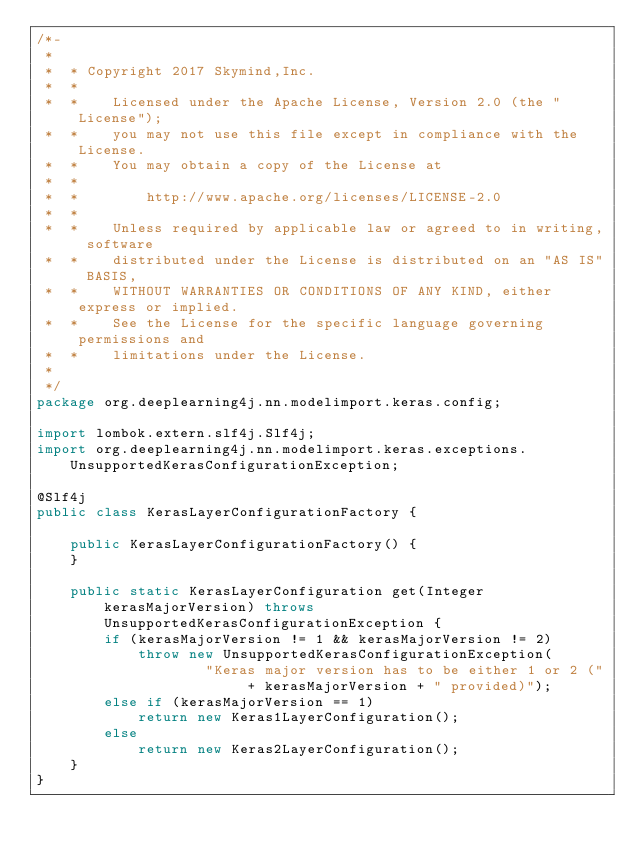<code> <loc_0><loc_0><loc_500><loc_500><_Java_>/*-
 *
 *  * Copyright 2017 Skymind,Inc.
 *  *
 *  *    Licensed under the Apache License, Version 2.0 (the "License");
 *  *    you may not use this file except in compliance with the License.
 *  *    You may obtain a copy of the License at
 *  *
 *  *        http://www.apache.org/licenses/LICENSE-2.0
 *  *
 *  *    Unless required by applicable law or agreed to in writing, software
 *  *    distributed under the License is distributed on an "AS IS" BASIS,
 *  *    WITHOUT WARRANTIES OR CONDITIONS OF ANY KIND, either express or implied.
 *  *    See the License for the specific language governing permissions and
 *  *    limitations under the License.
 *
 */
package org.deeplearning4j.nn.modelimport.keras.config;

import lombok.extern.slf4j.Slf4j;
import org.deeplearning4j.nn.modelimport.keras.exceptions.UnsupportedKerasConfigurationException;

@Slf4j
public class KerasLayerConfigurationFactory {

    public KerasLayerConfigurationFactory() {
    }

    public static KerasLayerConfiguration get(Integer kerasMajorVersion) throws UnsupportedKerasConfigurationException {
        if (kerasMajorVersion != 1 && kerasMajorVersion != 2)
            throw new UnsupportedKerasConfigurationException(
                    "Keras major version has to be either 1 or 2 (" + kerasMajorVersion + " provided)");
        else if (kerasMajorVersion == 1)
            return new Keras1LayerConfiguration();
        else
            return new Keras2LayerConfiguration();
    }
}
</code> 